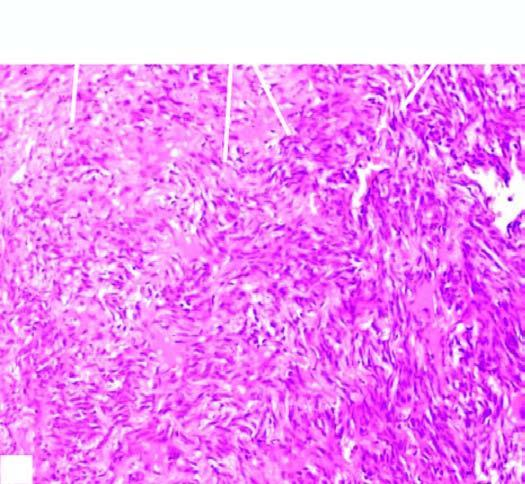does the cytoplasm show replacement of slaty-grey spongy parenchyma with multiple, firm, grey-white nodular masses, some having areas of haemorhages and necrosis?
Answer the question using a single word or phrase. No 